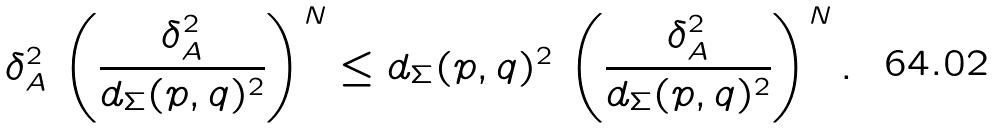<formula> <loc_0><loc_0><loc_500><loc_500>\delta _ { A } ^ { 2 } \, \left ( \frac { \delta _ { A } ^ { 2 } } { d _ { \Sigma } ( p , q ) ^ { 2 } } \right ) ^ { N } \leq d _ { \Sigma } ( p , q ) ^ { 2 } \, \left ( \frac { \delta _ { A } ^ { 2 } } { d _ { \Sigma } ( p , q ) ^ { 2 } } \right ) ^ { N } .</formula> 